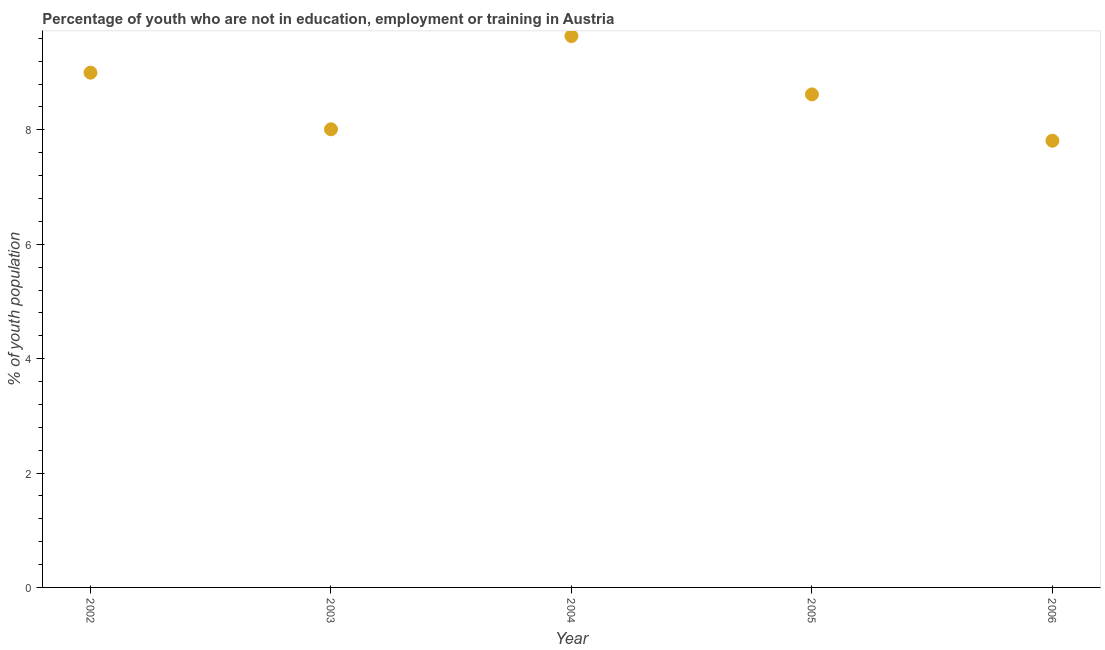What is the unemployed youth population in 2004?
Provide a succinct answer. 9.64. Across all years, what is the maximum unemployed youth population?
Keep it short and to the point. 9.64. Across all years, what is the minimum unemployed youth population?
Give a very brief answer. 7.81. What is the sum of the unemployed youth population?
Your answer should be compact. 43.08. What is the difference between the unemployed youth population in 2005 and 2006?
Offer a terse response. 0.81. What is the average unemployed youth population per year?
Provide a succinct answer. 8.62. What is the median unemployed youth population?
Offer a very short reply. 8.62. In how many years, is the unemployed youth population greater than 3.2 %?
Your answer should be compact. 5. Do a majority of the years between 2005 and 2002 (inclusive) have unemployed youth population greater than 2 %?
Your answer should be compact. Yes. What is the ratio of the unemployed youth population in 2004 to that in 2006?
Your answer should be compact. 1.23. Is the difference between the unemployed youth population in 2002 and 2005 greater than the difference between any two years?
Your answer should be compact. No. What is the difference between the highest and the second highest unemployed youth population?
Your answer should be very brief. 0.64. Is the sum of the unemployed youth population in 2002 and 2005 greater than the maximum unemployed youth population across all years?
Your response must be concise. Yes. What is the difference between the highest and the lowest unemployed youth population?
Your response must be concise. 1.83. Does the unemployed youth population monotonically increase over the years?
Offer a very short reply. No. How many years are there in the graph?
Provide a succinct answer. 5. What is the title of the graph?
Provide a short and direct response. Percentage of youth who are not in education, employment or training in Austria. What is the label or title of the X-axis?
Your answer should be compact. Year. What is the label or title of the Y-axis?
Give a very brief answer. % of youth population. What is the % of youth population in 2003?
Keep it short and to the point. 8.01. What is the % of youth population in 2004?
Keep it short and to the point. 9.64. What is the % of youth population in 2005?
Ensure brevity in your answer.  8.62. What is the % of youth population in 2006?
Your answer should be compact. 7.81. What is the difference between the % of youth population in 2002 and 2003?
Offer a very short reply. 0.99. What is the difference between the % of youth population in 2002 and 2004?
Offer a very short reply. -0.64. What is the difference between the % of youth population in 2002 and 2005?
Offer a very short reply. 0.38. What is the difference between the % of youth population in 2002 and 2006?
Ensure brevity in your answer.  1.19. What is the difference between the % of youth population in 2003 and 2004?
Keep it short and to the point. -1.63. What is the difference between the % of youth population in 2003 and 2005?
Give a very brief answer. -0.61. What is the difference between the % of youth population in 2003 and 2006?
Your answer should be very brief. 0.2. What is the difference between the % of youth population in 2004 and 2006?
Your answer should be compact. 1.83. What is the difference between the % of youth population in 2005 and 2006?
Offer a terse response. 0.81. What is the ratio of the % of youth population in 2002 to that in 2003?
Ensure brevity in your answer.  1.12. What is the ratio of the % of youth population in 2002 to that in 2004?
Your answer should be very brief. 0.93. What is the ratio of the % of youth population in 2002 to that in 2005?
Give a very brief answer. 1.04. What is the ratio of the % of youth population in 2002 to that in 2006?
Provide a succinct answer. 1.15. What is the ratio of the % of youth population in 2003 to that in 2004?
Provide a succinct answer. 0.83. What is the ratio of the % of youth population in 2003 to that in 2005?
Ensure brevity in your answer.  0.93. What is the ratio of the % of youth population in 2003 to that in 2006?
Your answer should be compact. 1.03. What is the ratio of the % of youth population in 2004 to that in 2005?
Provide a succinct answer. 1.12. What is the ratio of the % of youth population in 2004 to that in 2006?
Provide a succinct answer. 1.23. What is the ratio of the % of youth population in 2005 to that in 2006?
Ensure brevity in your answer.  1.1. 